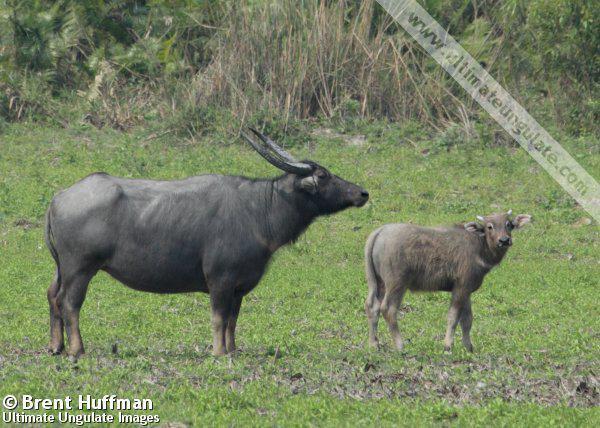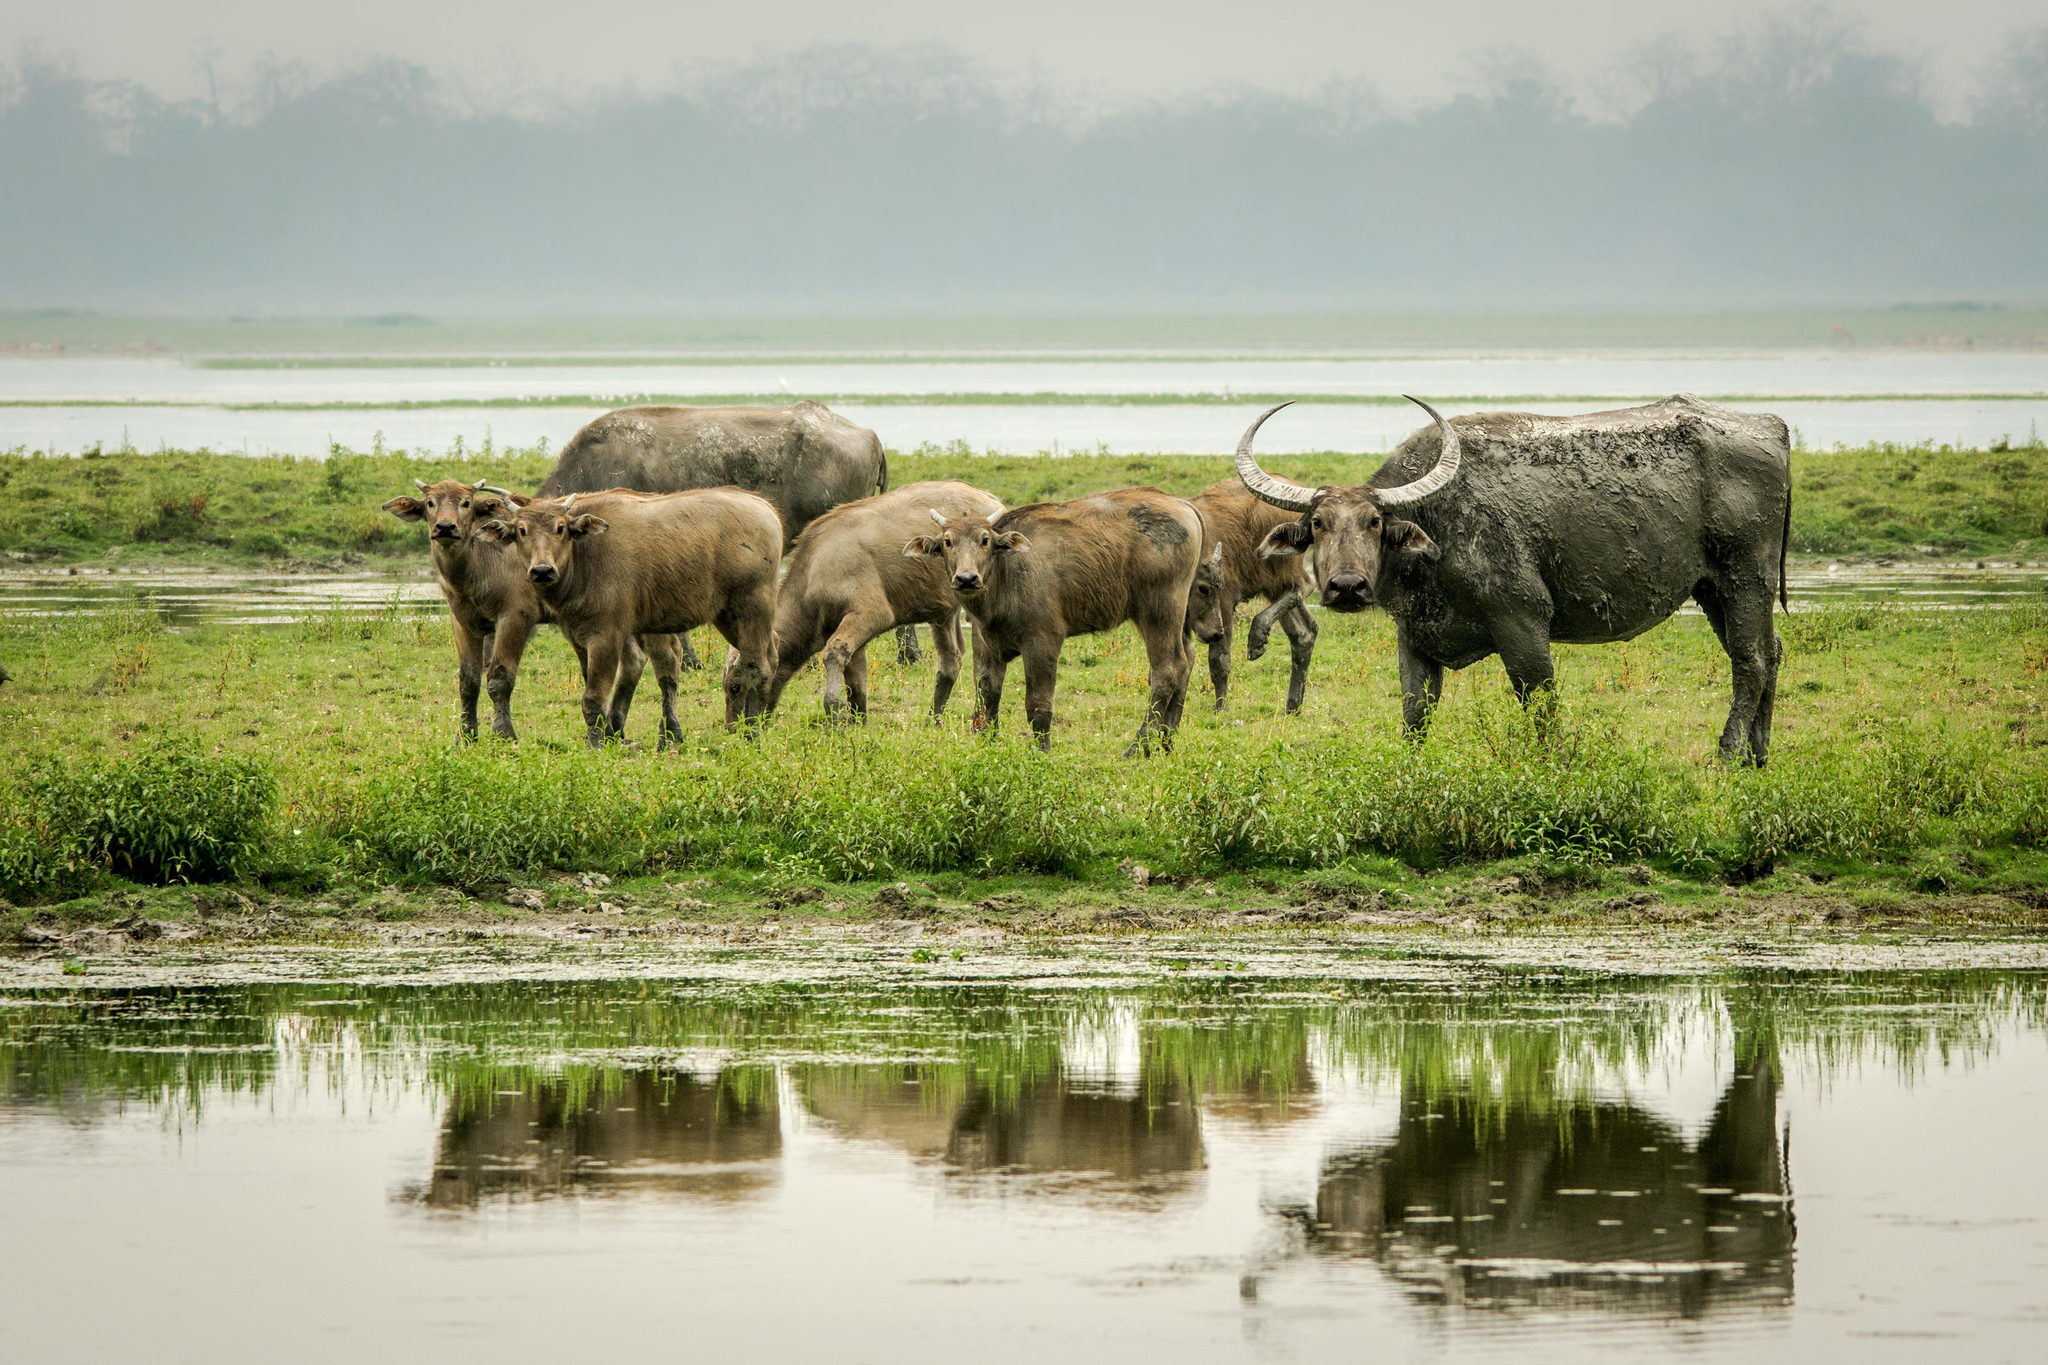The first image is the image on the left, the second image is the image on the right. Considering the images on both sides, is "There are exactly three animals in each set of images." valid? Answer yes or no. No. The first image is the image on the left, the second image is the image on the right. Given the left and right images, does the statement "One image shows exactly two water buffalo, both in profile." hold true? Answer yes or no. Yes. The first image is the image on the left, the second image is the image on the right. Analyze the images presented: Is the assertion "A water buffalo is walking through water in one image." valid? Answer yes or no. No. The first image is the image on the left, the second image is the image on the right. Examine the images to the left and right. Is the description "Each image contains just one water buffalo." accurate? Answer yes or no. No. The first image is the image on the left, the second image is the image on the right. Evaluate the accuracy of this statement regarding the images: "A water buffalo happens to be in the water, in one of the images.". Is it true? Answer yes or no. No. The first image is the image on the left, the second image is the image on the right. Given the left and right images, does the statement "At least one ox is standing in the water." hold true? Answer yes or no. No. 